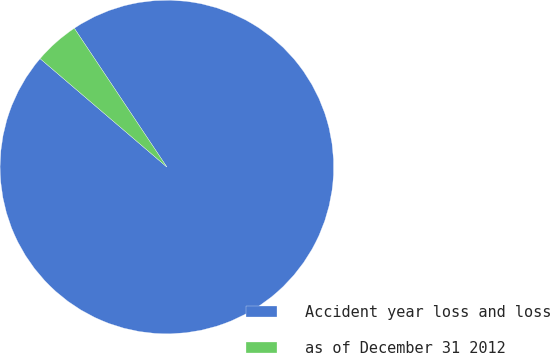<chart> <loc_0><loc_0><loc_500><loc_500><pie_chart><fcel>Accident year loss and loss<fcel>as of December 31 2012<nl><fcel>95.62%<fcel>4.38%<nl></chart> 